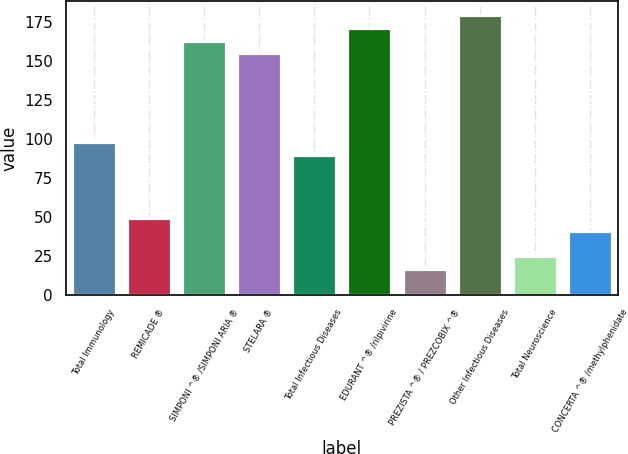Convert chart to OTSL. <chart><loc_0><loc_0><loc_500><loc_500><bar_chart><fcel>Total Immunology<fcel>REMICADE ®<fcel>SIMPONI ^® /SIMPONI ARIA ®<fcel>STELARA ®<fcel>Total Infectious Diseases<fcel>EDURANT ^® /rilpivirine<fcel>PREZISTA ^® / PREZCOBIX ^®<fcel>Other Infectious Diseases<fcel>Total Neuroscience<fcel>CONCERTA ^® /methylphenidate<nl><fcel>97.86<fcel>49.08<fcel>162.9<fcel>154.77<fcel>89.73<fcel>171.03<fcel>16.56<fcel>179.16<fcel>24.69<fcel>40.95<nl></chart> 